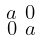<formula> <loc_0><loc_0><loc_500><loc_500>\begin{smallmatrix} a & 0 \\ 0 & a \end{smallmatrix}</formula> 